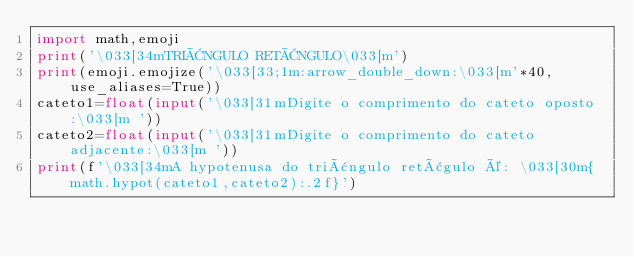<code> <loc_0><loc_0><loc_500><loc_500><_Python_>import math,emoji
print('\033[34mTRIÂNGULO RETÂNGULO\033[m')
print(emoji.emojize('\033[33;1m:arrow_double_down:\033[m'*40, use_aliases=True))
cateto1=float(input('\033[31mDigite o comprimento do cateto oposto:\033[m '))
cateto2=float(input('\033[31mDigite o comprimento do cateto adjacente:\033[m '))
print(f'\033[34mA hypotenusa do triângulo retâgulo é: \033[30m{math.hypot(cateto1,cateto2):.2f}')</code> 